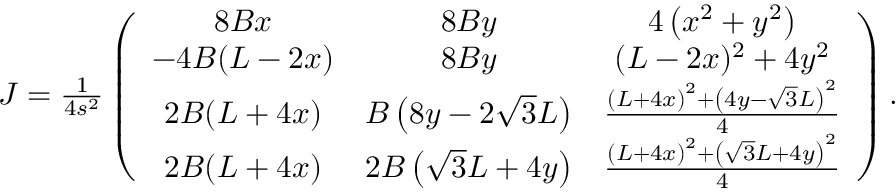<formula> <loc_0><loc_0><loc_500><loc_500>\begin{array} { r } { J = \frac { 1 } 4 s ^ { 2 } } \left ( \begin{array} { c c c } { 8 B x } & { 8 B y } & { 4 \left ( x ^ { 2 } + y ^ { 2 } \right ) } \\ { - 4 B ( L - 2 x ) } & { 8 B y } & { ( L - 2 x ) ^ { 2 } + 4 y ^ { 2 } } \\ { 2 B ( L + 4 x ) } & { B \left ( 8 y - 2 \sqrt { 3 } L \right ) } & { \frac { \left ( L + 4 x \right ) ^ { 2 } + \left ( 4 y - \sqrt { 3 } L \right ) ^ { 2 } } { 4 } } \\ { 2 B ( L + 4 x ) } & { 2 B \left ( \sqrt { 3 } L + 4 y \right ) } & { \frac { \left ( L + 4 x \right ) ^ { 2 } + \left ( \sqrt { 3 } L + 4 y \right ) ^ { 2 } } { 4 } } \end{array} \right ) . } \end{array}</formula> 